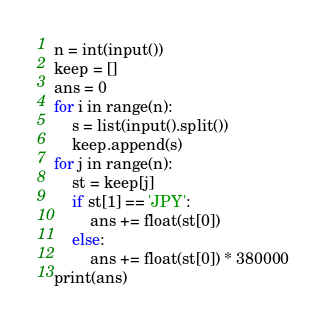Convert code to text. <code><loc_0><loc_0><loc_500><loc_500><_Python_>n = int(input())
keep = []
ans = 0
for i in range(n):
    s = list(input().split())
    keep.append(s)
for j in range(n):
    st = keep[j]
    if st[1] == 'JPY':
        ans += float(st[0])
    else:
        ans += float(st[0]) * 380000
print(ans)
</code> 